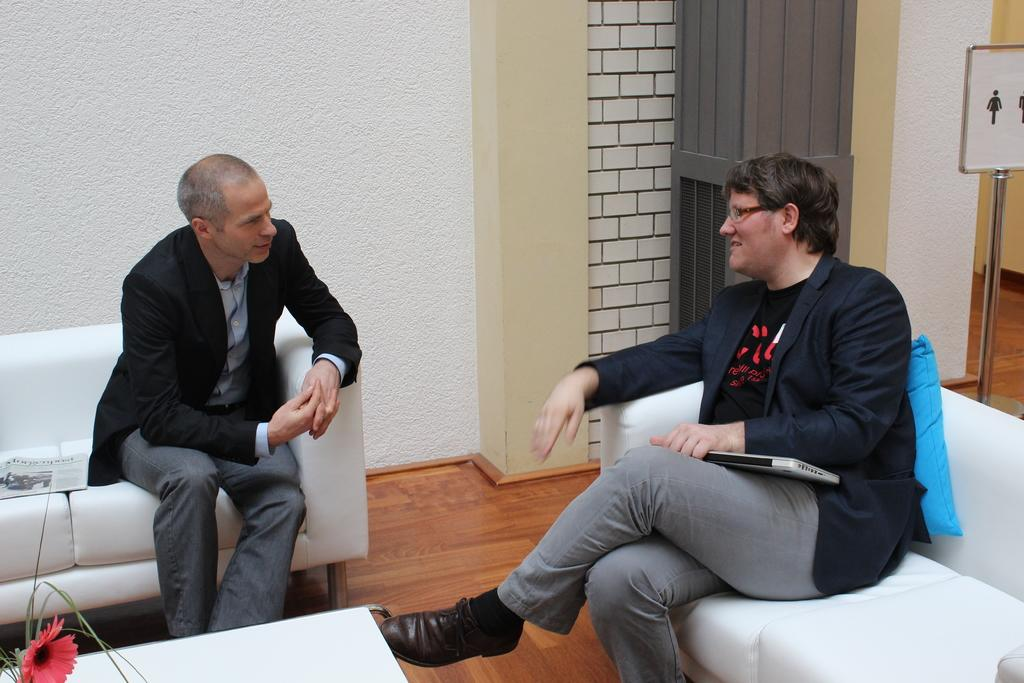How many people are in the image? There are two people in the image. What are the people wearing? Both people are wearing black suits. Where are the people sitting in the image? The people are sitting on a sofa. How many frogs can be seen hopping around the people in the image? There are no frogs present in the image; it features two people sitting on a sofa while wearing black suits. 